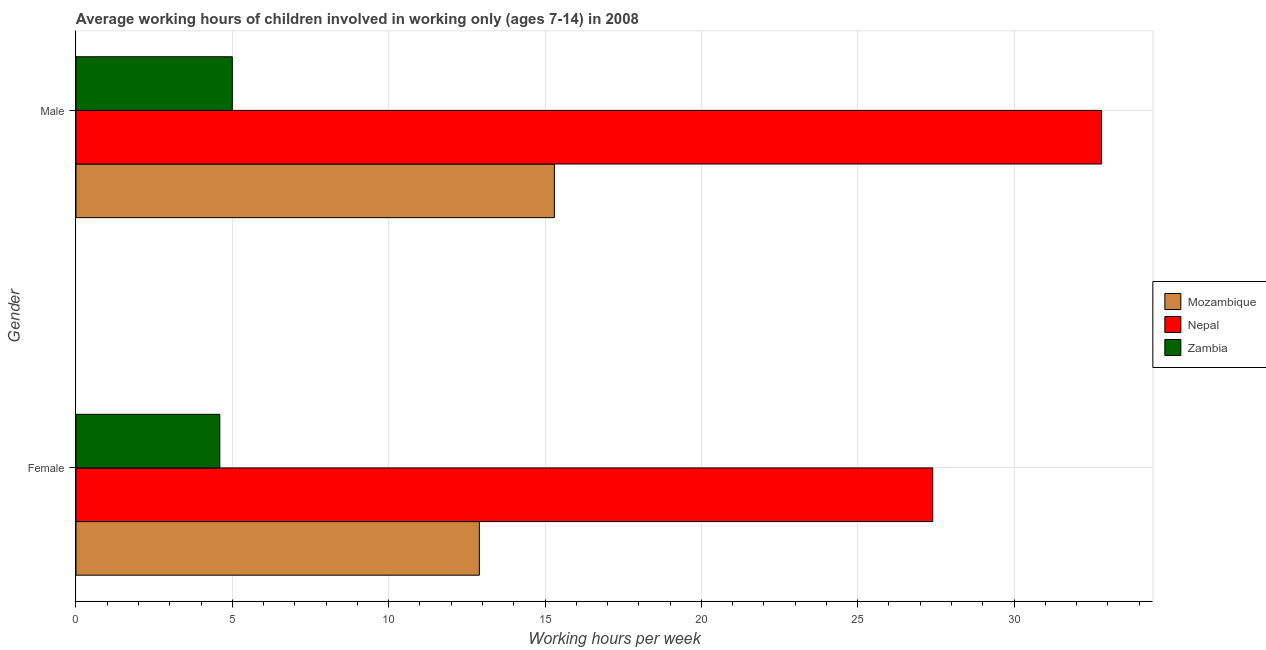How many different coloured bars are there?
Keep it short and to the point. 3. What is the label of the 2nd group of bars from the top?
Offer a very short reply. Female. What is the average working hour of female children in Zambia?
Offer a very short reply. 4.6. Across all countries, what is the maximum average working hour of male children?
Provide a short and direct response. 32.8. Across all countries, what is the minimum average working hour of female children?
Keep it short and to the point. 4.6. In which country was the average working hour of female children maximum?
Make the answer very short. Nepal. In which country was the average working hour of female children minimum?
Offer a very short reply. Zambia. What is the total average working hour of female children in the graph?
Offer a terse response. 44.9. What is the difference between the average working hour of female children in Nepal and the average working hour of male children in Mozambique?
Keep it short and to the point. 12.1. What is the average average working hour of female children per country?
Ensure brevity in your answer.  14.97. What is the difference between the average working hour of female children and average working hour of male children in Nepal?
Your response must be concise. -5.4. In how many countries, is the average working hour of male children greater than 21 hours?
Your response must be concise. 1. What is the ratio of the average working hour of male children in Mozambique to that in Zambia?
Your answer should be very brief. 3.06. In how many countries, is the average working hour of female children greater than the average average working hour of female children taken over all countries?
Keep it short and to the point. 1. What does the 2nd bar from the top in Female represents?
Offer a terse response. Nepal. What does the 2nd bar from the bottom in Female represents?
Offer a very short reply. Nepal. Does the graph contain any zero values?
Ensure brevity in your answer.  No. Does the graph contain grids?
Give a very brief answer. Yes. Where does the legend appear in the graph?
Your answer should be compact. Center right. What is the title of the graph?
Offer a terse response. Average working hours of children involved in working only (ages 7-14) in 2008. What is the label or title of the X-axis?
Offer a terse response. Working hours per week. What is the Working hours per week in Mozambique in Female?
Your response must be concise. 12.9. What is the Working hours per week in Nepal in Female?
Your response must be concise. 27.4. What is the Working hours per week in Zambia in Female?
Ensure brevity in your answer.  4.6. What is the Working hours per week in Nepal in Male?
Your answer should be very brief. 32.8. What is the Working hours per week of Zambia in Male?
Ensure brevity in your answer.  5. Across all Gender, what is the maximum Working hours per week of Nepal?
Provide a succinct answer. 32.8. Across all Gender, what is the maximum Working hours per week in Zambia?
Offer a terse response. 5. Across all Gender, what is the minimum Working hours per week in Mozambique?
Ensure brevity in your answer.  12.9. Across all Gender, what is the minimum Working hours per week of Nepal?
Offer a very short reply. 27.4. What is the total Working hours per week of Mozambique in the graph?
Ensure brevity in your answer.  28.2. What is the total Working hours per week of Nepal in the graph?
Your answer should be very brief. 60.2. What is the total Working hours per week in Zambia in the graph?
Provide a succinct answer. 9.6. What is the difference between the Working hours per week in Mozambique in Female and that in Male?
Your answer should be very brief. -2.4. What is the difference between the Working hours per week in Nepal in Female and that in Male?
Offer a very short reply. -5.4. What is the difference between the Working hours per week in Zambia in Female and that in Male?
Offer a terse response. -0.4. What is the difference between the Working hours per week in Mozambique in Female and the Working hours per week in Nepal in Male?
Your answer should be compact. -19.9. What is the difference between the Working hours per week in Mozambique in Female and the Working hours per week in Zambia in Male?
Offer a very short reply. 7.9. What is the difference between the Working hours per week of Nepal in Female and the Working hours per week of Zambia in Male?
Offer a very short reply. 22.4. What is the average Working hours per week in Nepal per Gender?
Keep it short and to the point. 30.1. What is the average Working hours per week in Zambia per Gender?
Provide a short and direct response. 4.8. What is the difference between the Working hours per week in Nepal and Working hours per week in Zambia in Female?
Your response must be concise. 22.8. What is the difference between the Working hours per week of Mozambique and Working hours per week of Nepal in Male?
Offer a terse response. -17.5. What is the difference between the Working hours per week of Mozambique and Working hours per week of Zambia in Male?
Give a very brief answer. 10.3. What is the difference between the Working hours per week in Nepal and Working hours per week in Zambia in Male?
Offer a very short reply. 27.8. What is the ratio of the Working hours per week in Mozambique in Female to that in Male?
Offer a very short reply. 0.84. What is the ratio of the Working hours per week in Nepal in Female to that in Male?
Provide a short and direct response. 0.84. What is the difference between the highest and the second highest Working hours per week of Mozambique?
Give a very brief answer. 2.4. What is the difference between the highest and the lowest Working hours per week of Nepal?
Offer a very short reply. 5.4. What is the difference between the highest and the lowest Working hours per week in Zambia?
Provide a succinct answer. 0.4. 